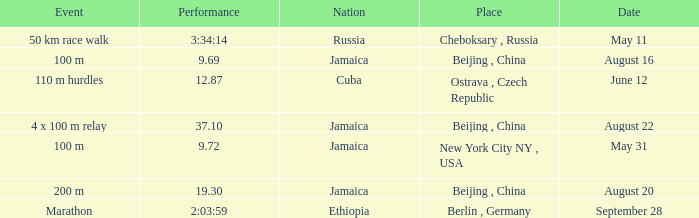What is the Place associated with Cuba? Ostrava , Czech Republic. 